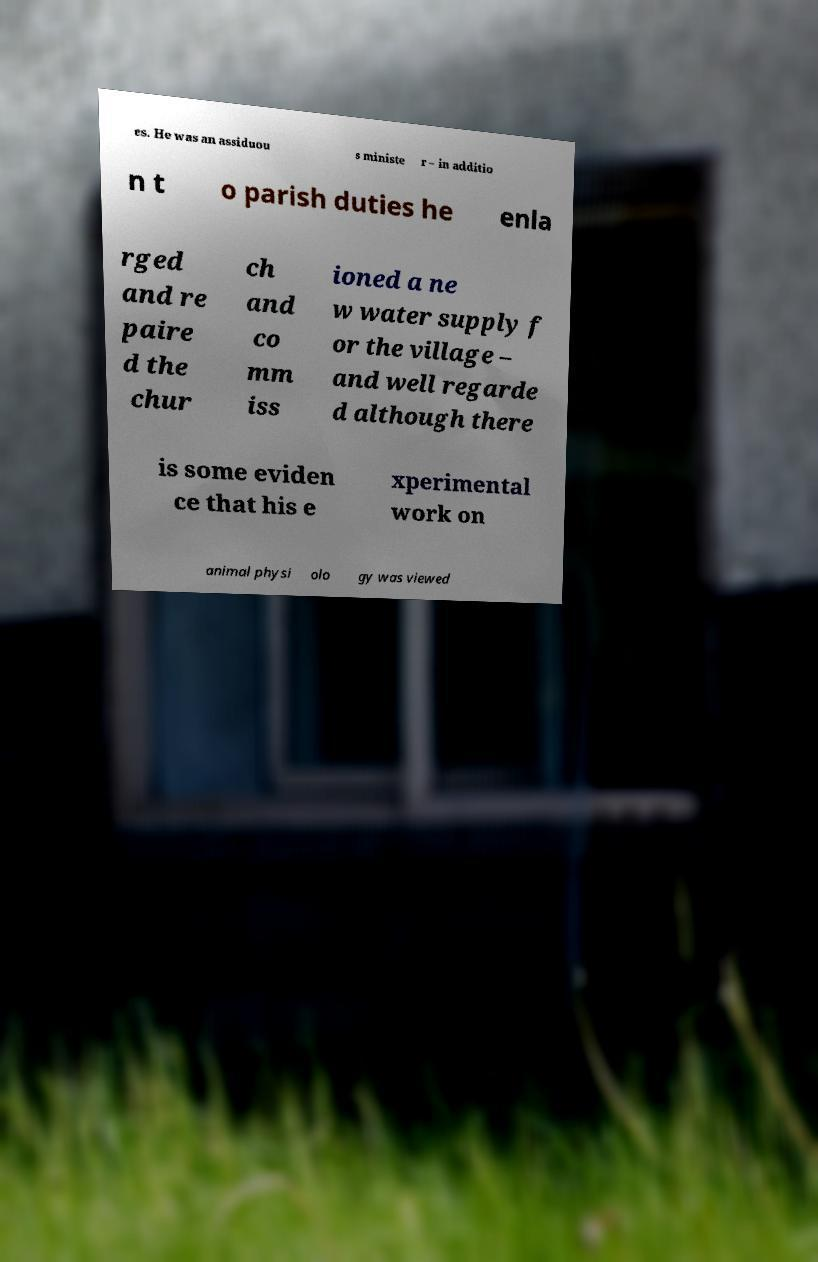For documentation purposes, I need the text within this image transcribed. Could you provide that? es. He was an assiduou s ministe r – in additio n t o parish duties he enla rged and re paire d the chur ch and co mm iss ioned a ne w water supply f or the village – and well regarde d although there is some eviden ce that his e xperimental work on animal physi olo gy was viewed 